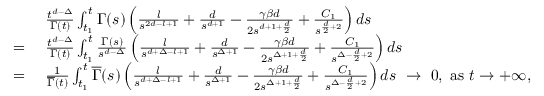<formula> <loc_0><loc_0><loc_500><loc_500>\begin{array} { r l } & { \frac { t ^ { d - \Delta } } { \Gamma ( t ) } \int _ { t _ { 1 } } ^ { t } \Gamma ( s ) \left ( \frac { l } { s ^ { 2 d - l + 1 } } + \frac { d } { s ^ { d + 1 } } - \frac { \gamma \beta d } { 2 s ^ { d + 1 + \frac { d } { 2 } } } + \frac { C _ { 1 } } { s ^ { \frac { d } { 2 } + 2 } } \right ) d s } \\ { = \ } & { \frac { t ^ { d - \Delta } } { \Gamma ( t ) } \int _ { t _ { 1 } } ^ { t } \frac { \Gamma ( s ) } { s ^ { d - \Delta } } \left ( \frac { l } { s ^ { d + \Delta - l + 1 } } + \frac { d } { s ^ { \Delta + 1 } } - \frac { \gamma \beta d } { 2 s ^ { \Delta + 1 + \frac { d } { 2 } } } + \frac { C _ { 1 } } { s ^ { \Delta - \frac { d } { 2 } + 2 } } \right ) d s } \\ { = \ } & { \frac { 1 } { \overline { \Gamma } ( t ) } \int _ { t _ { 1 } } ^ { t } \overline { \Gamma } ( s ) \left ( \frac { l } { s ^ { d + \Delta - l + 1 } } + \frac { d } { s ^ { \Delta + 1 } } - \frac { \gamma \beta d } { 2 s ^ { \Delta + 1 + \frac { d } { 2 } } } + \frac { C _ { 1 } } { s ^ { \Delta - \frac { d } { 2 } + 2 } } \right ) d s \ \to \ 0 , a s t \to + \infty , } \end{array}</formula> 